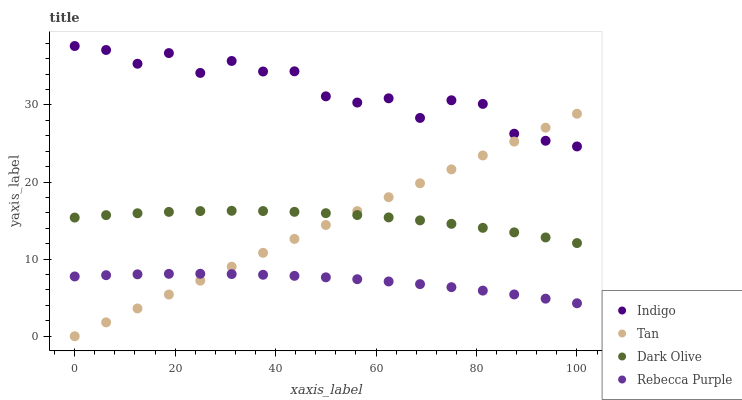Does Rebecca Purple have the minimum area under the curve?
Answer yes or no. Yes. Does Indigo have the maximum area under the curve?
Answer yes or no. Yes. Does Dark Olive have the minimum area under the curve?
Answer yes or no. No. Does Dark Olive have the maximum area under the curve?
Answer yes or no. No. Is Tan the smoothest?
Answer yes or no. Yes. Is Indigo the roughest?
Answer yes or no. Yes. Is Dark Olive the smoothest?
Answer yes or no. No. Is Dark Olive the roughest?
Answer yes or no. No. Does Tan have the lowest value?
Answer yes or no. Yes. Does Dark Olive have the lowest value?
Answer yes or no. No. Does Indigo have the highest value?
Answer yes or no. Yes. Does Dark Olive have the highest value?
Answer yes or no. No. Is Rebecca Purple less than Indigo?
Answer yes or no. Yes. Is Dark Olive greater than Rebecca Purple?
Answer yes or no. Yes. Does Tan intersect Dark Olive?
Answer yes or no. Yes. Is Tan less than Dark Olive?
Answer yes or no. No. Is Tan greater than Dark Olive?
Answer yes or no. No. Does Rebecca Purple intersect Indigo?
Answer yes or no. No. 